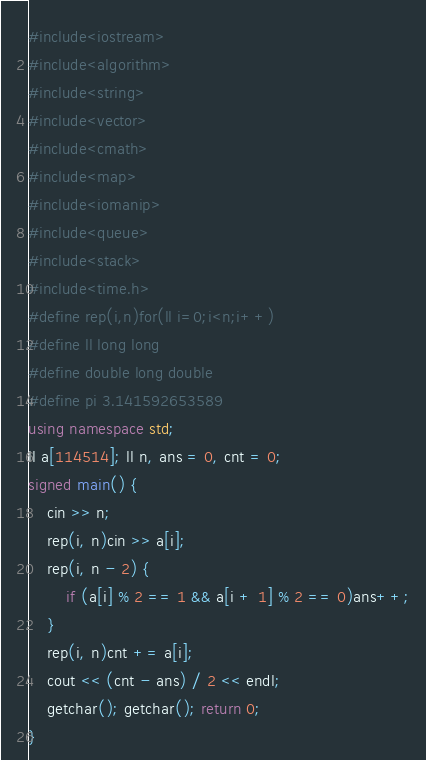<code> <loc_0><loc_0><loc_500><loc_500><_C++_>#include<iostream>
#include<algorithm>
#include<string>
#include<vector>
#include<cmath>
#include<map>
#include<iomanip>
#include<queue>
#include<stack>
#include<time.h>
#define rep(i,n)for(ll i=0;i<n;i++)
#define ll long long
#define double long double
#define pi 3.141592653589
using namespace std;
ll a[114514]; ll n, ans = 0, cnt = 0;
signed main() {
	cin >> n;
	rep(i, n)cin >> a[i];
	rep(i, n - 2) {
		if (a[i] % 2 == 1 && a[i + 1] % 2 == 0)ans++;
	}
	rep(i, n)cnt += a[i];
	cout << (cnt - ans) / 2 << endl;
	getchar(); getchar(); return 0;
}</code> 